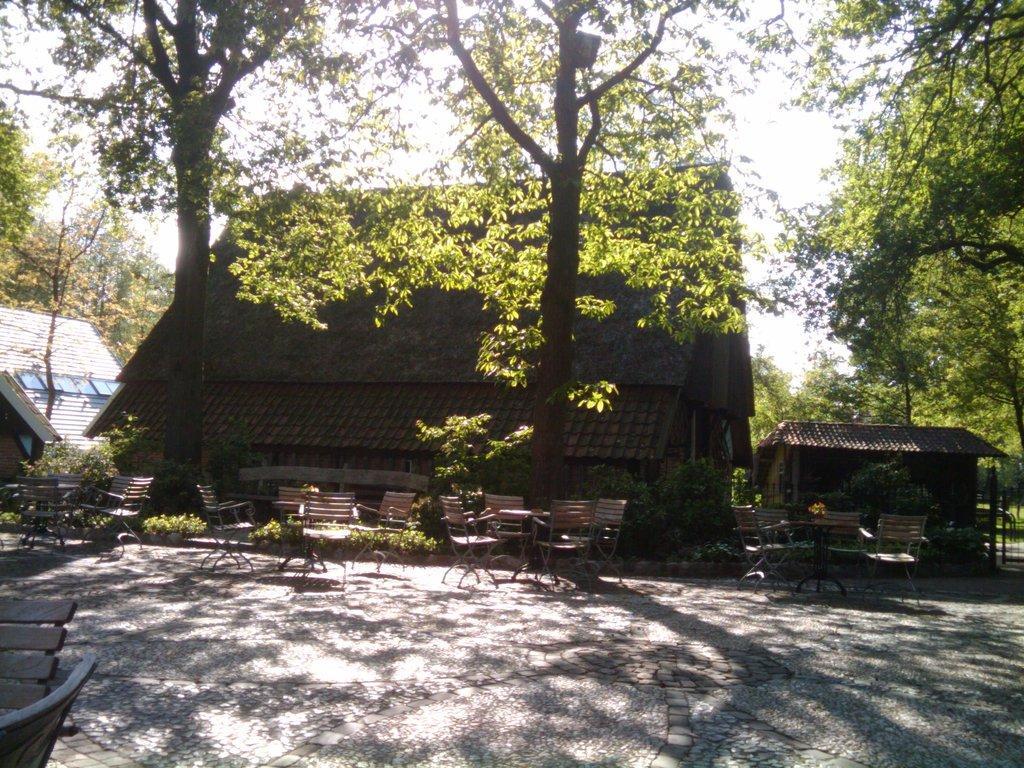Please provide a concise description of this image. In this image I can see few chairs. In the background I can see the building in maroon color, trees in green color and sky in white color. 